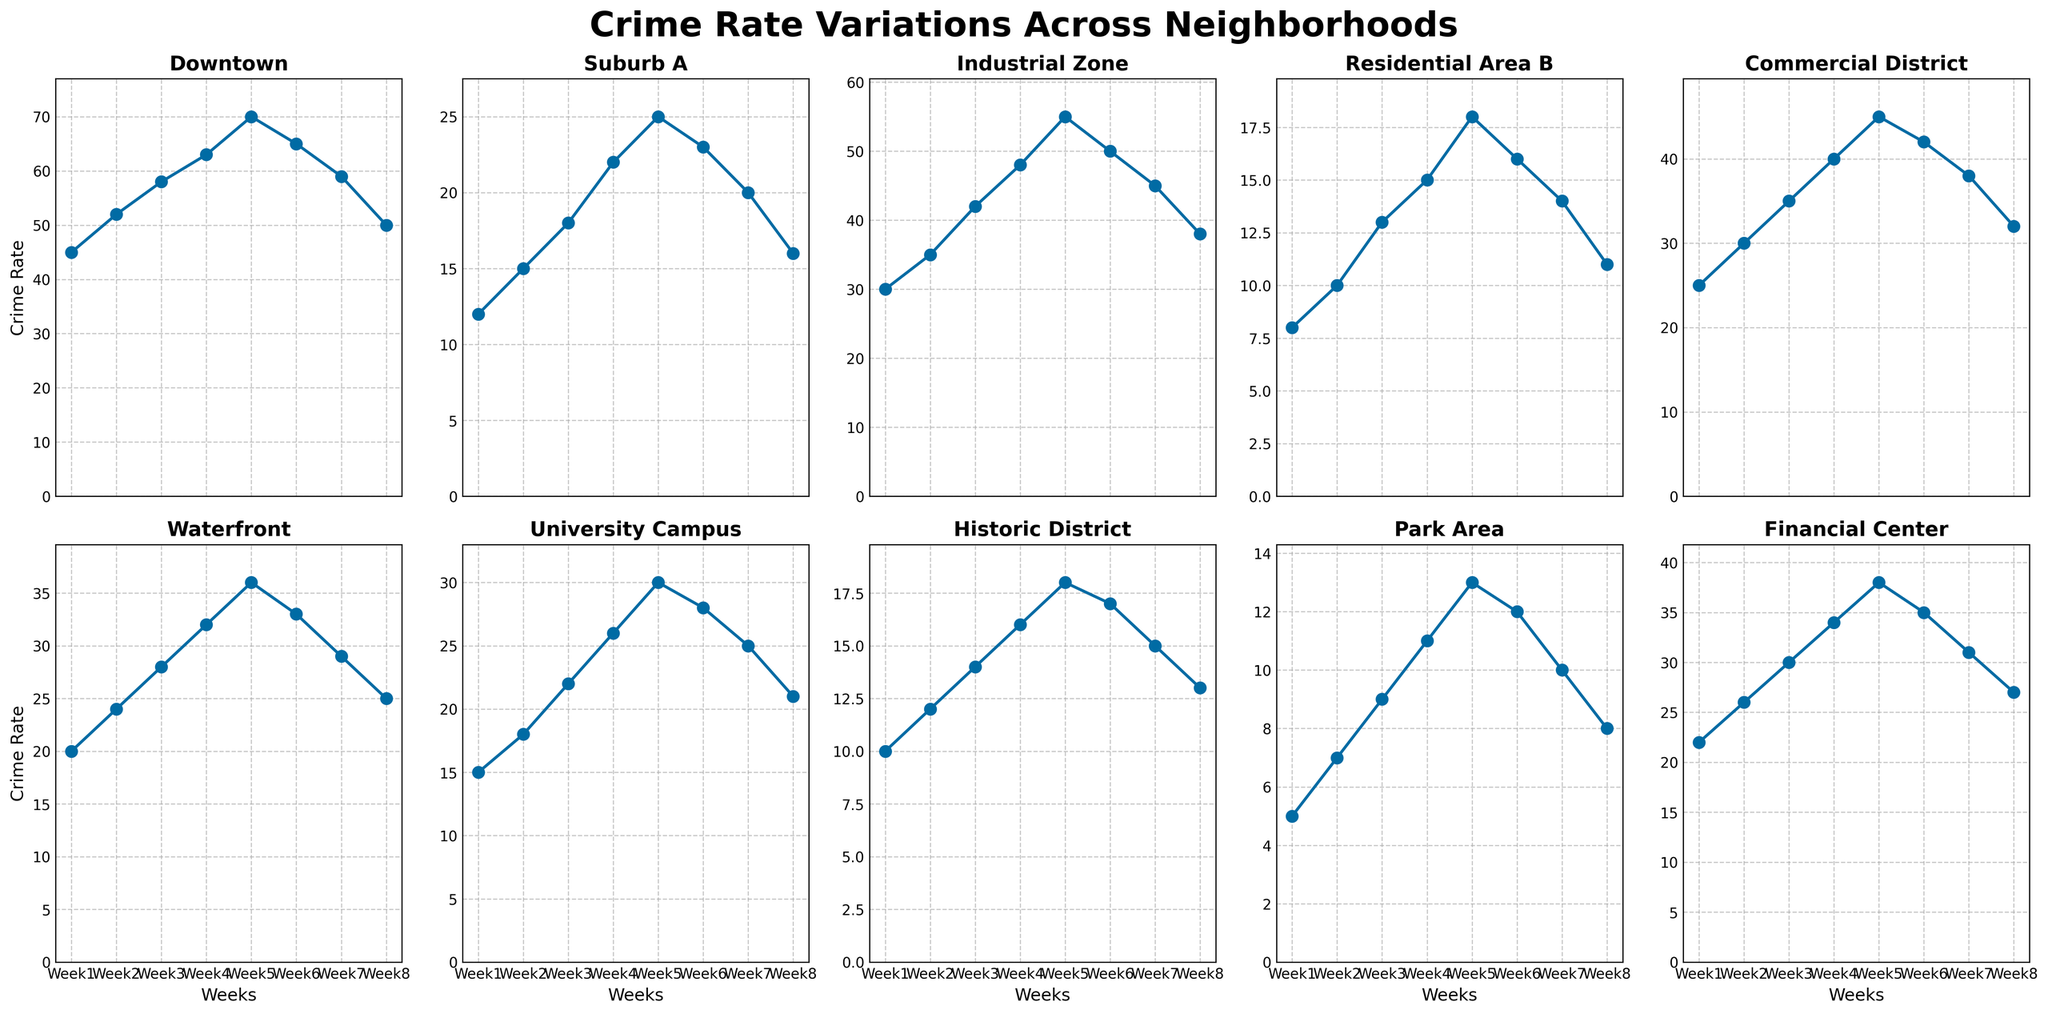What's the average crime rate for the Downtown neighborhood over the 8 weeks? Sum the crime rates for Downtown (45 + 52 + 58 + 63 + 70 + 65 + 59 + 50 = 462) and divide by the number of weeks (8). The average is 462 / 8 = 57.75
Answer: 57.75 Which neighborhood experienced the highest crime rate in Week 5? Compare the crime rates of all neighborhoods in Week 5, the highest is Downtown with a crime rate of 70.
Answer: Downtown Which neighborhood had the most significant decrease in crime rate from Week 5 to Week 8? Subtract the Week 8 crime rate from the Week 5 rate for each neighborhood and identify the largest negative difference. Downtown saw a decrease from 70 to 50, which is the largest decrease of 20.
Answer: Downtown Between University Campus and Commercial District, which had a higher crime rate trend in the first 4 weeks? Compare the sum of crime rates for the first 4 weeks for both neighborhoods. University Campus (15 + 18 + 22 + 26 = 81), Commercial District (25 + 30 + 35 + 40 = 130). Commercial District had a higher trend.
Answer: Commercial District How does the crime rate change in the Waterfront area correlate with the Industrial Zone over the 8 weeks? Compare the general trend of both areas. Both Waterfront and Industrial Zone show an increasing trend up to Week 5 and then a decrease, indicating a similar pattern.
Answer: Similar increasing and decreasing trend What is the total increase in crime rate in the Park Area from Week 1 to Week 5? Subtract Week 1 crime rate from Week 5 crime rate in Park Area (13 - 5 = 8).
Answer: 8 Which neighborhood exhibited the most stable crime rate trend over the 8 weeks? Examine the graphs and determine which neighborhood's crime rate fluctuates the least. Historic District shows the most stable pattern, with very small increases each week.
Answer: Historic District How many neighborhoods had their peak crime rate in Week 5? Count the neighborhoods where the highest crime rate for them is in Week 5. Downtown, Suburb A, Industrial Zone, Commercial District, Waterfront, University Campus, Financial Center all peaked in Week 5, total is 7.
Answer: 7 